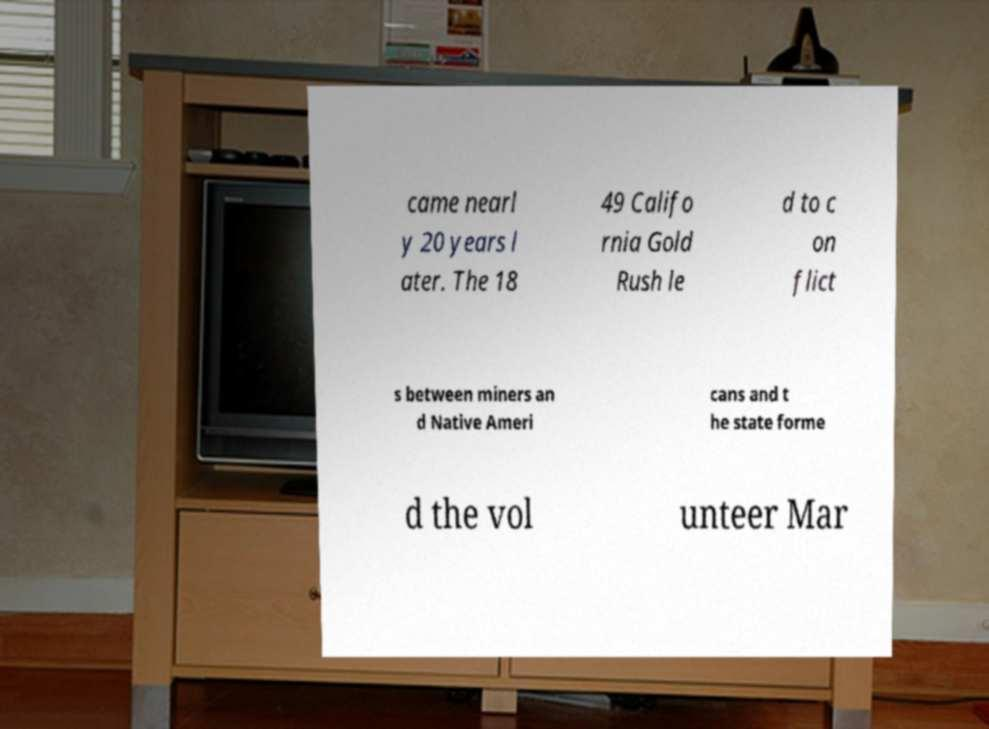I need the written content from this picture converted into text. Can you do that? came nearl y 20 years l ater. The 18 49 Califo rnia Gold Rush le d to c on flict s between miners an d Native Ameri cans and t he state forme d the vol unteer Mar 